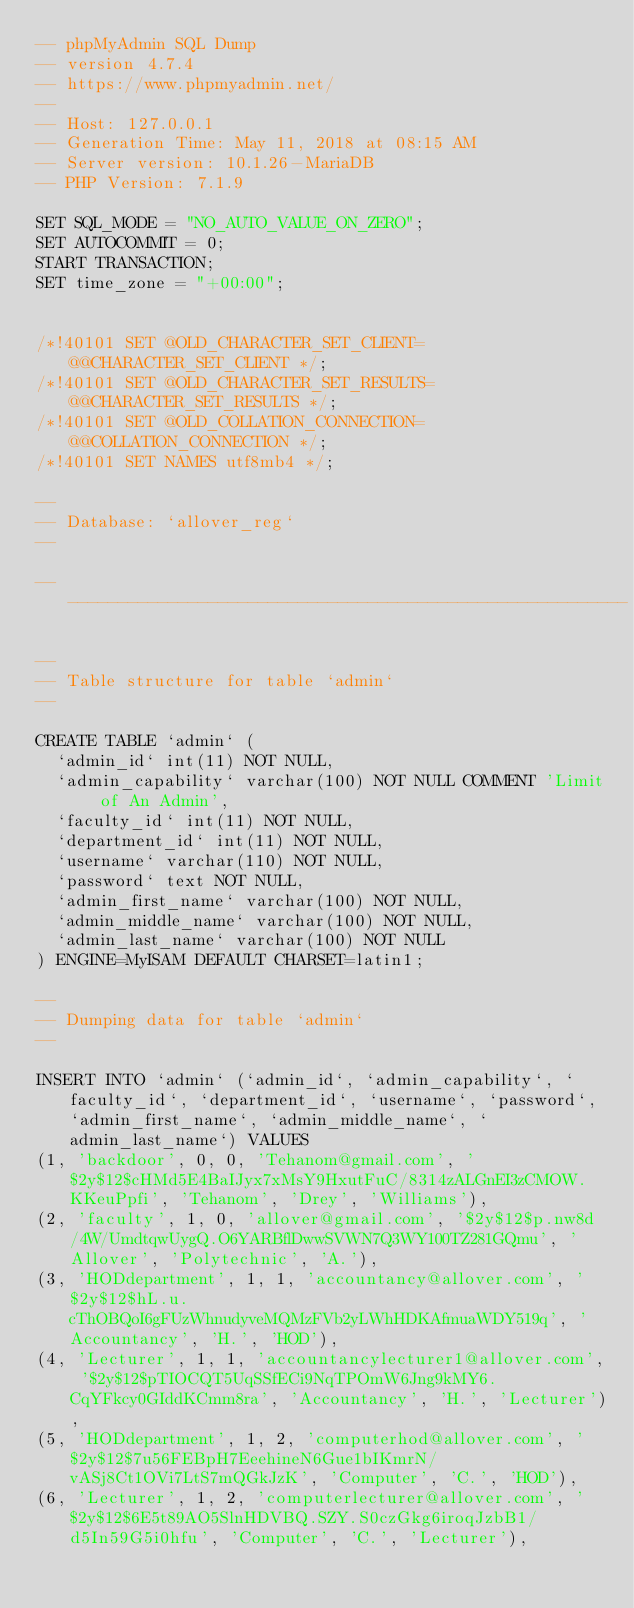<code> <loc_0><loc_0><loc_500><loc_500><_SQL_>-- phpMyAdmin SQL Dump
-- version 4.7.4
-- https://www.phpmyadmin.net/
--
-- Host: 127.0.0.1
-- Generation Time: May 11, 2018 at 08:15 AM
-- Server version: 10.1.26-MariaDB
-- PHP Version: 7.1.9

SET SQL_MODE = "NO_AUTO_VALUE_ON_ZERO";
SET AUTOCOMMIT = 0;
START TRANSACTION;
SET time_zone = "+00:00";


/*!40101 SET @OLD_CHARACTER_SET_CLIENT=@@CHARACTER_SET_CLIENT */;
/*!40101 SET @OLD_CHARACTER_SET_RESULTS=@@CHARACTER_SET_RESULTS */;
/*!40101 SET @OLD_COLLATION_CONNECTION=@@COLLATION_CONNECTION */;
/*!40101 SET NAMES utf8mb4 */;

--
-- Database: `allover_reg`
--

-- --------------------------------------------------------

--
-- Table structure for table `admin`
--

CREATE TABLE `admin` (
  `admin_id` int(11) NOT NULL,
  `admin_capability` varchar(100) NOT NULL COMMENT 'Limit of An Admin',
  `faculty_id` int(11) NOT NULL,
  `department_id` int(11) NOT NULL,
  `username` varchar(110) NOT NULL,
  `password` text NOT NULL,
  `admin_first_name` varchar(100) NOT NULL,
  `admin_middle_name` varchar(100) NOT NULL,
  `admin_last_name` varchar(100) NOT NULL
) ENGINE=MyISAM DEFAULT CHARSET=latin1;

--
-- Dumping data for table `admin`
--

INSERT INTO `admin` (`admin_id`, `admin_capability`, `faculty_id`, `department_id`, `username`, `password`, `admin_first_name`, `admin_middle_name`, `admin_last_name`) VALUES
(1, 'backdoor', 0, 0, 'Tehanom@gmail.com', '$2y$12$cHMd5E4BaIJyx7xMsY9HxutFuC/8314zALGnEI3zCMOW.KKeuPpfi', 'Tehanom', 'Drey', 'Williams'),
(2, 'faculty', 1, 0, 'allover@gmail.com', '$2y$12$p.nw8d/4W/UmdtqwUygQ.O6YARBflDwwSVWN7Q3WY100TZ281GQmu', 'Allover', 'Polytechnic', 'A.'),
(3, 'HODdepartment', 1, 1, 'accountancy@allover.com', '$2y$12$hL.u.cThOBQoI6gFUzWhnudyveMQMzFVb2yLWhHDKAfmuaWDY519q', 'Accountancy', 'H.', 'HOD'),
(4, 'Lecturer', 1, 1, 'accountancylecturer1@allover.com', '$2y$12$pTIOCQT5UqSSfECi9NqTPOmW6Jng9kMY6.CqYFkcy0GIddKCmm8ra', 'Accountancy', 'H.', 'Lecturer'),
(5, 'HODdepartment', 1, 2, 'computerhod@allover.com', '$2y$12$7u56FEBpH7EeehineN6Gue1bIKmrN/vASj8Ct1OVi7LtS7mQGkJzK', 'Computer', 'C.', 'HOD'),
(6, 'Lecturer', 1, 2, 'computerlecturer@allover.com', '$2y$12$6E5t89AO5SlnHDVBQ.SZY.S0czGkg6iroqJzbB1/d5In59G5i0hfu', 'Computer', 'C.', 'Lecturer'),</code> 